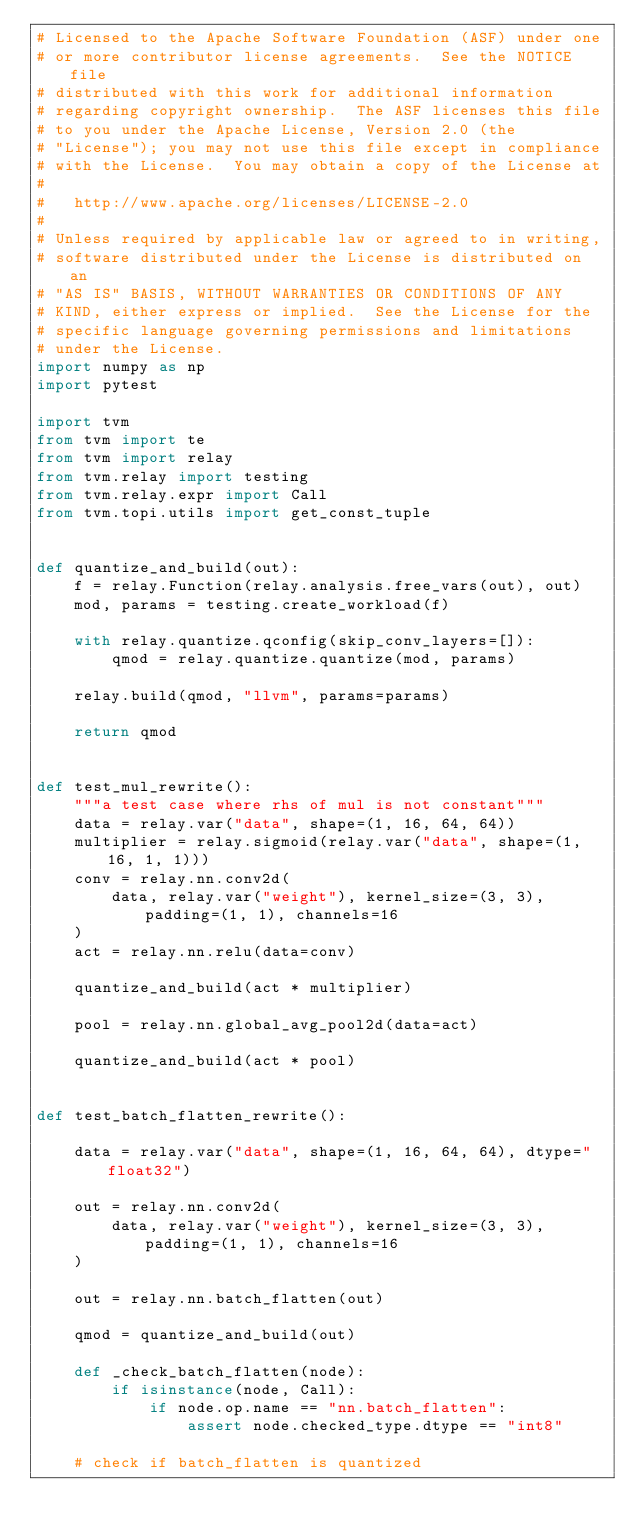<code> <loc_0><loc_0><loc_500><loc_500><_Python_># Licensed to the Apache Software Foundation (ASF) under one
# or more contributor license agreements.  See the NOTICE file
# distributed with this work for additional information
# regarding copyright ownership.  The ASF licenses this file
# to you under the Apache License, Version 2.0 (the
# "License"); you may not use this file except in compliance
# with the License.  You may obtain a copy of the License at
#
#   http://www.apache.org/licenses/LICENSE-2.0
#
# Unless required by applicable law or agreed to in writing,
# software distributed under the License is distributed on an
# "AS IS" BASIS, WITHOUT WARRANTIES OR CONDITIONS OF ANY
# KIND, either express or implied.  See the License for the
# specific language governing permissions and limitations
# under the License.
import numpy as np
import pytest

import tvm
from tvm import te
from tvm import relay
from tvm.relay import testing
from tvm.relay.expr import Call
from tvm.topi.utils import get_const_tuple


def quantize_and_build(out):
    f = relay.Function(relay.analysis.free_vars(out), out)
    mod, params = testing.create_workload(f)

    with relay.quantize.qconfig(skip_conv_layers=[]):
        qmod = relay.quantize.quantize(mod, params)

    relay.build(qmod, "llvm", params=params)

    return qmod


def test_mul_rewrite():
    """a test case where rhs of mul is not constant"""
    data = relay.var("data", shape=(1, 16, 64, 64))
    multiplier = relay.sigmoid(relay.var("data", shape=(1, 16, 1, 1)))
    conv = relay.nn.conv2d(
        data, relay.var("weight"), kernel_size=(3, 3), padding=(1, 1), channels=16
    )
    act = relay.nn.relu(data=conv)

    quantize_and_build(act * multiplier)

    pool = relay.nn.global_avg_pool2d(data=act)

    quantize_and_build(act * pool)


def test_batch_flatten_rewrite():

    data = relay.var("data", shape=(1, 16, 64, 64), dtype="float32")

    out = relay.nn.conv2d(
        data, relay.var("weight"), kernel_size=(3, 3), padding=(1, 1), channels=16
    )

    out = relay.nn.batch_flatten(out)

    qmod = quantize_and_build(out)

    def _check_batch_flatten(node):
        if isinstance(node, Call):
            if node.op.name == "nn.batch_flatten":
                assert node.checked_type.dtype == "int8"

    # check if batch_flatten is quantized</code> 